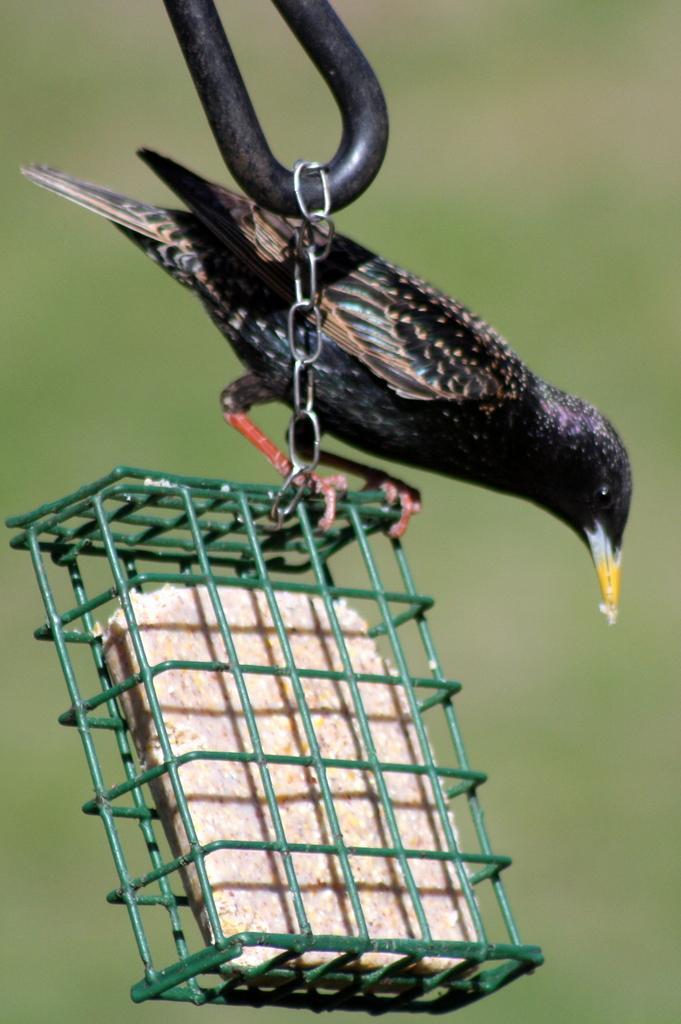In one or two sentences, can you explain what this image depicts? In the image we can see a bird, small cage, food in a cage and this is a chain. 